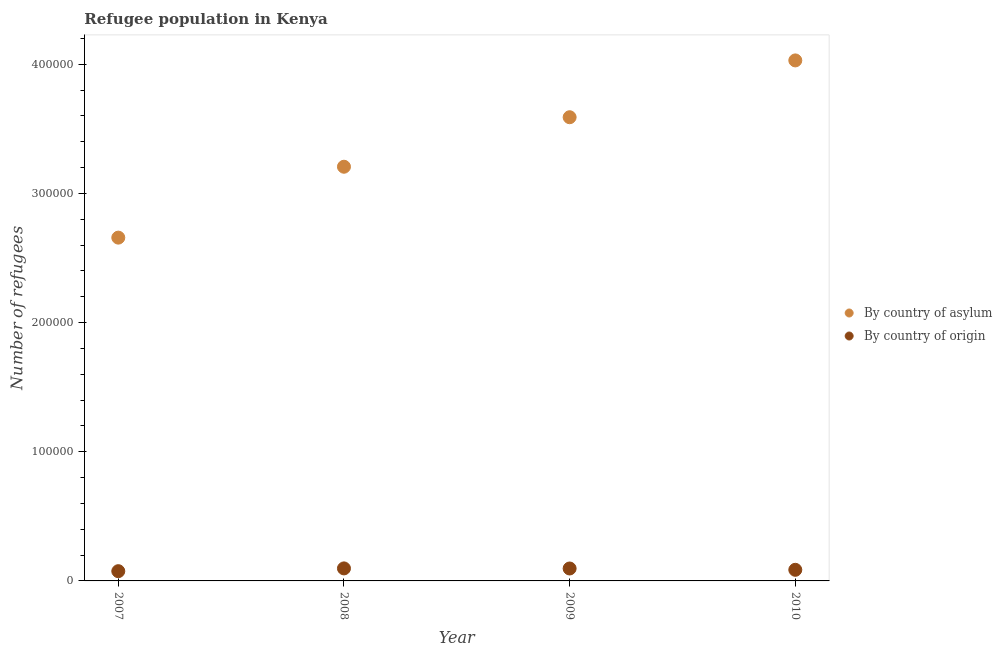How many different coloured dotlines are there?
Give a very brief answer. 2. What is the number of refugees by country of asylum in 2007?
Offer a terse response. 2.66e+05. Across all years, what is the maximum number of refugees by country of asylum?
Ensure brevity in your answer.  4.03e+05. Across all years, what is the minimum number of refugees by country of origin?
Ensure brevity in your answer.  7546. In which year was the number of refugees by country of asylum maximum?
Your response must be concise. 2010. What is the total number of refugees by country of asylum in the graph?
Make the answer very short. 1.35e+06. What is the difference between the number of refugees by country of asylum in 2008 and that in 2009?
Give a very brief answer. -3.83e+04. What is the difference between the number of refugees by country of asylum in 2007 and the number of refugees by country of origin in 2010?
Offer a terse response. 2.57e+05. What is the average number of refugees by country of origin per year?
Keep it short and to the point. 8864. In the year 2010, what is the difference between the number of refugees by country of asylum and number of refugees by country of origin?
Your answer should be very brief. 3.94e+05. What is the ratio of the number of refugees by country of origin in 2008 to that in 2010?
Offer a very short reply. 1.13. Is the number of refugees by country of origin in 2008 less than that in 2010?
Make the answer very short. No. What is the difference between the highest and the second highest number of refugees by country of asylum?
Provide a succinct answer. 4.40e+04. What is the difference between the highest and the lowest number of refugees by country of origin?
Your answer should be very brief. 2142. In how many years, is the number of refugees by country of asylum greater than the average number of refugees by country of asylum taken over all years?
Your answer should be compact. 2. Is the number of refugees by country of asylum strictly less than the number of refugees by country of origin over the years?
Your response must be concise. No. How many years are there in the graph?
Make the answer very short. 4. Are the values on the major ticks of Y-axis written in scientific E-notation?
Your answer should be very brief. No. Does the graph contain grids?
Provide a short and direct response. No. Where does the legend appear in the graph?
Your answer should be very brief. Center right. How many legend labels are there?
Keep it short and to the point. 2. How are the legend labels stacked?
Your answer should be very brief. Vertical. What is the title of the graph?
Give a very brief answer. Refugee population in Kenya. What is the label or title of the X-axis?
Make the answer very short. Year. What is the label or title of the Y-axis?
Offer a very short reply. Number of refugees. What is the Number of refugees of By country of asylum in 2007?
Provide a short and direct response. 2.66e+05. What is the Number of refugees in By country of origin in 2007?
Keep it short and to the point. 7546. What is the Number of refugees in By country of asylum in 2008?
Provide a short and direct response. 3.21e+05. What is the Number of refugees in By country of origin in 2008?
Provide a succinct answer. 9688. What is the Number of refugees of By country of asylum in 2009?
Your answer should be compact. 3.59e+05. What is the Number of refugees of By country of origin in 2009?
Keep it short and to the point. 9620. What is the Number of refugees in By country of asylum in 2010?
Offer a terse response. 4.03e+05. What is the Number of refugees in By country of origin in 2010?
Offer a very short reply. 8602. Across all years, what is the maximum Number of refugees of By country of asylum?
Ensure brevity in your answer.  4.03e+05. Across all years, what is the maximum Number of refugees in By country of origin?
Your response must be concise. 9688. Across all years, what is the minimum Number of refugees in By country of asylum?
Give a very brief answer. 2.66e+05. Across all years, what is the minimum Number of refugees in By country of origin?
Offer a terse response. 7546. What is the total Number of refugees in By country of asylum in the graph?
Provide a short and direct response. 1.35e+06. What is the total Number of refugees of By country of origin in the graph?
Provide a succinct answer. 3.55e+04. What is the difference between the Number of refugees in By country of asylum in 2007 and that in 2008?
Offer a very short reply. -5.49e+04. What is the difference between the Number of refugees of By country of origin in 2007 and that in 2008?
Your answer should be very brief. -2142. What is the difference between the Number of refugees of By country of asylum in 2007 and that in 2009?
Your answer should be very brief. -9.32e+04. What is the difference between the Number of refugees of By country of origin in 2007 and that in 2009?
Keep it short and to the point. -2074. What is the difference between the Number of refugees of By country of asylum in 2007 and that in 2010?
Offer a very short reply. -1.37e+05. What is the difference between the Number of refugees of By country of origin in 2007 and that in 2010?
Your response must be concise. -1056. What is the difference between the Number of refugees of By country of asylum in 2008 and that in 2009?
Ensure brevity in your answer.  -3.83e+04. What is the difference between the Number of refugees of By country of origin in 2008 and that in 2009?
Provide a short and direct response. 68. What is the difference between the Number of refugees in By country of asylum in 2008 and that in 2010?
Keep it short and to the point. -8.23e+04. What is the difference between the Number of refugees of By country of origin in 2008 and that in 2010?
Your response must be concise. 1086. What is the difference between the Number of refugees in By country of asylum in 2009 and that in 2010?
Provide a short and direct response. -4.40e+04. What is the difference between the Number of refugees of By country of origin in 2009 and that in 2010?
Your answer should be compact. 1018. What is the difference between the Number of refugees of By country of asylum in 2007 and the Number of refugees of By country of origin in 2008?
Ensure brevity in your answer.  2.56e+05. What is the difference between the Number of refugees in By country of asylum in 2007 and the Number of refugees in By country of origin in 2009?
Your answer should be compact. 2.56e+05. What is the difference between the Number of refugees in By country of asylum in 2007 and the Number of refugees in By country of origin in 2010?
Offer a terse response. 2.57e+05. What is the difference between the Number of refugees of By country of asylum in 2008 and the Number of refugees of By country of origin in 2009?
Give a very brief answer. 3.11e+05. What is the difference between the Number of refugees of By country of asylum in 2008 and the Number of refugees of By country of origin in 2010?
Your response must be concise. 3.12e+05. What is the difference between the Number of refugees in By country of asylum in 2009 and the Number of refugees in By country of origin in 2010?
Provide a succinct answer. 3.50e+05. What is the average Number of refugees in By country of asylum per year?
Your answer should be compact. 3.37e+05. What is the average Number of refugees of By country of origin per year?
Give a very brief answer. 8864. In the year 2007, what is the difference between the Number of refugees of By country of asylum and Number of refugees of By country of origin?
Your response must be concise. 2.58e+05. In the year 2008, what is the difference between the Number of refugees in By country of asylum and Number of refugees in By country of origin?
Keep it short and to the point. 3.11e+05. In the year 2009, what is the difference between the Number of refugees of By country of asylum and Number of refugees of By country of origin?
Ensure brevity in your answer.  3.49e+05. In the year 2010, what is the difference between the Number of refugees in By country of asylum and Number of refugees in By country of origin?
Your answer should be compact. 3.94e+05. What is the ratio of the Number of refugees in By country of asylum in 2007 to that in 2008?
Provide a succinct answer. 0.83. What is the ratio of the Number of refugees of By country of origin in 2007 to that in 2008?
Provide a short and direct response. 0.78. What is the ratio of the Number of refugees in By country of asylum in 2007 to that in 2009?
Your response must be concise. 0.74. What is the ratio of the Number of refugees of By country of origin in 2007 to that in 2009?
Your answer should be very brief. 0.78. What is the ratio of the Number of refugees of By country of asylum in 2007 to that in 2010?
Your answer should be very brief. 0.66. What is the ratio of the Number of refugees in By country of origin in 2007 to that in 2010?
Offer a terse response. 0.88. What is the ratio of the Number of refugees in By country of asylum in 2008 to that in 2009?
Your answer should be compact. 0.89. What is the ratio of the Number of refugees of By country of origin in 2008 to that in 2009?
Your answer should be very brief. 1.01. What is the ratio of the Number of refugees of By country of asylum in 2008 to that in 2010?
Ensure brevity in your answer.  0.8. What is the ratio of the Number of refugees of By country of origin in 2008 to that in 2010?
Give a very brief answer. 1.13. What is the ratio of the Number of refugees in By country of asylum in 2009 to that in 2010?
Your response must be concise. 0.89. What is the ratio of the Number of refugees in By country of origin in 2009 to that in 2010?
Offer a very short reply. 1.12. What is the difference between the highest and the second highest Number of refugees in By country of asylum?
Provide a succinct answer. 4.40e+04. What is the difference between the highest and the lowest Number of refugees in By country of asylum?
Your answer should be very brief. 1.37e+05. What is the difference between the highest and the lowest Number of refugees of By country of origin?
Provide a short and direct response. 2142. 